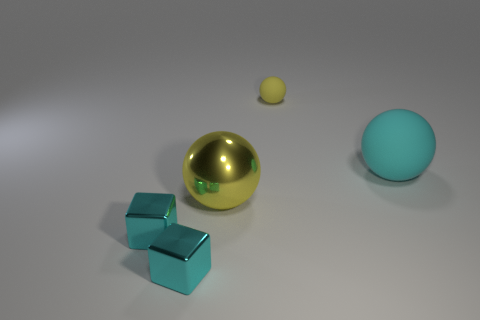Add 4 matte spheres. How many objects exist? 9 Subtract all cubes. How many objects are left? 3 Subtract 0 red spheres. How many objects are left? 5 Subtract all yellow matte balls. Subtract all large objects. How many objects are left? 2 Add 2 yellow matte spheres. How many yellow matte spheres are left? 3 Add 2 cyan rubber things. How many cyan rubber things exist? 3 